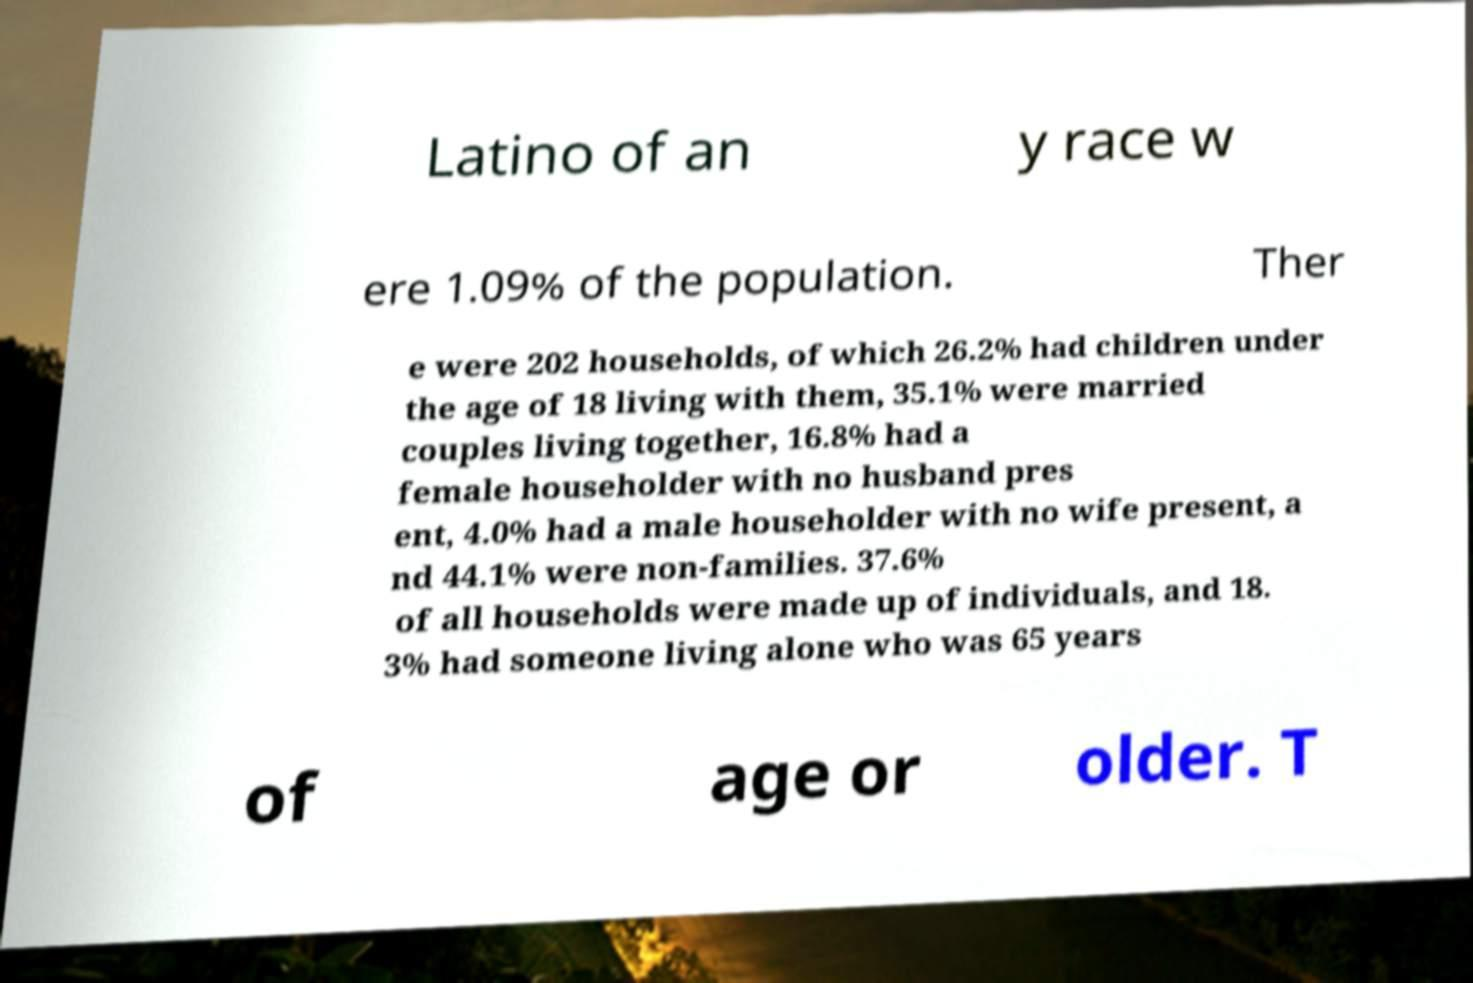What messages or text are displayed in this image? I need them in a readable, typed format. Latino of an y race w ere 1.09% of the population. Ther e were 202 households, of which 26.2% had children under the age of 18 living with them, 35.1% were married couples living together, 16.8% had a female householder with no husband pres ent, 4.0% had a male householder with no wife present, a nd 44.1% were non-families. 37.6% of all households were made up of individuals, and 18. 3% had someone living alone who was 65 years of age or older. T 